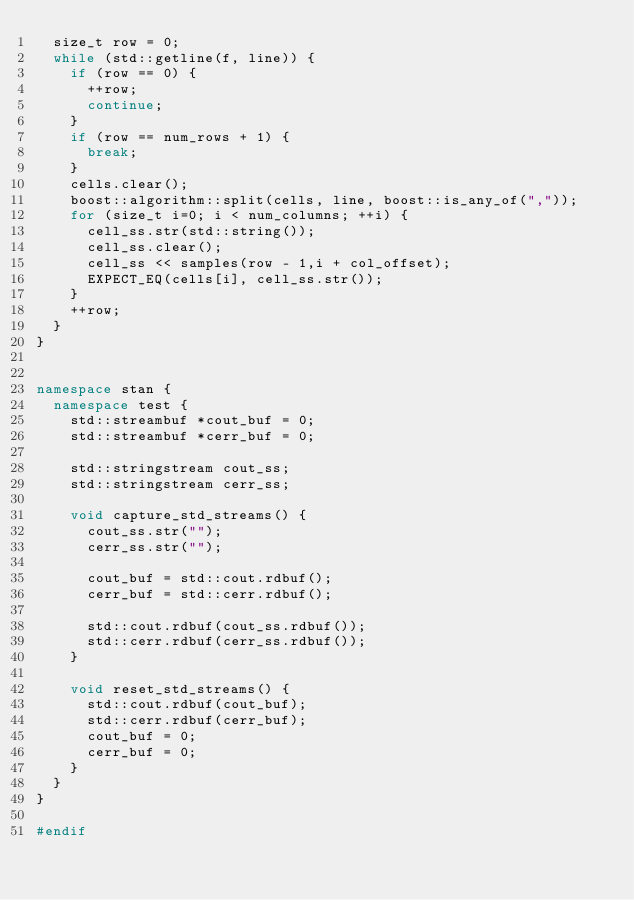Convert code to text. <code><loc_0><loc_0><loc_500><loc_500><_C++_>  size_t row = 0;
  while (std::getline(f, line)) {
    if (row == 0) {
      ++row;
      continue;
    } 
    if (row == num_rows + 1) {
      break;
    } 
    cells.clear();
    boost::algorithm::split(cells, line, boost::is_any_of(","));
    for (size_t i=0; i < num_columns; ++i) {
      cell_ss.str(std::string());
      cell_ss.clear();
      cell_ss << samples(row - 1,i + col_offset);
      EXPECT_EQ(cells[i], cell_ss.str());
    }
    ++row;
  }
}


namespace stan {
  namespace test {
    std::streambuf *cout_buf = 0;
    std::streambuf *cerr_buf = 0;

    std::stringstream cout_ss;
    std::stringstream cerr_ss;

    void capture_std_streams() {
      cout_ss.str("");
      cerr_ss.str("");

      cout_buf = std::cout.rdbuf();
      cerr_buf = std::cerr.rdbuf();

      std::cout.rdbuf(cout_ss.rdbuf());
      std::cerr.rdbuf(cerr_ss.rdbuf());
    }

    void reset_std_streams() {
      std::cout.rdbuf(cout_buf);
      std::cerr.rdbuf(cerr_buf);
      cout_buf = 0;
      cerr_buf = 0;
    }
  }
}

#endif
</code> 